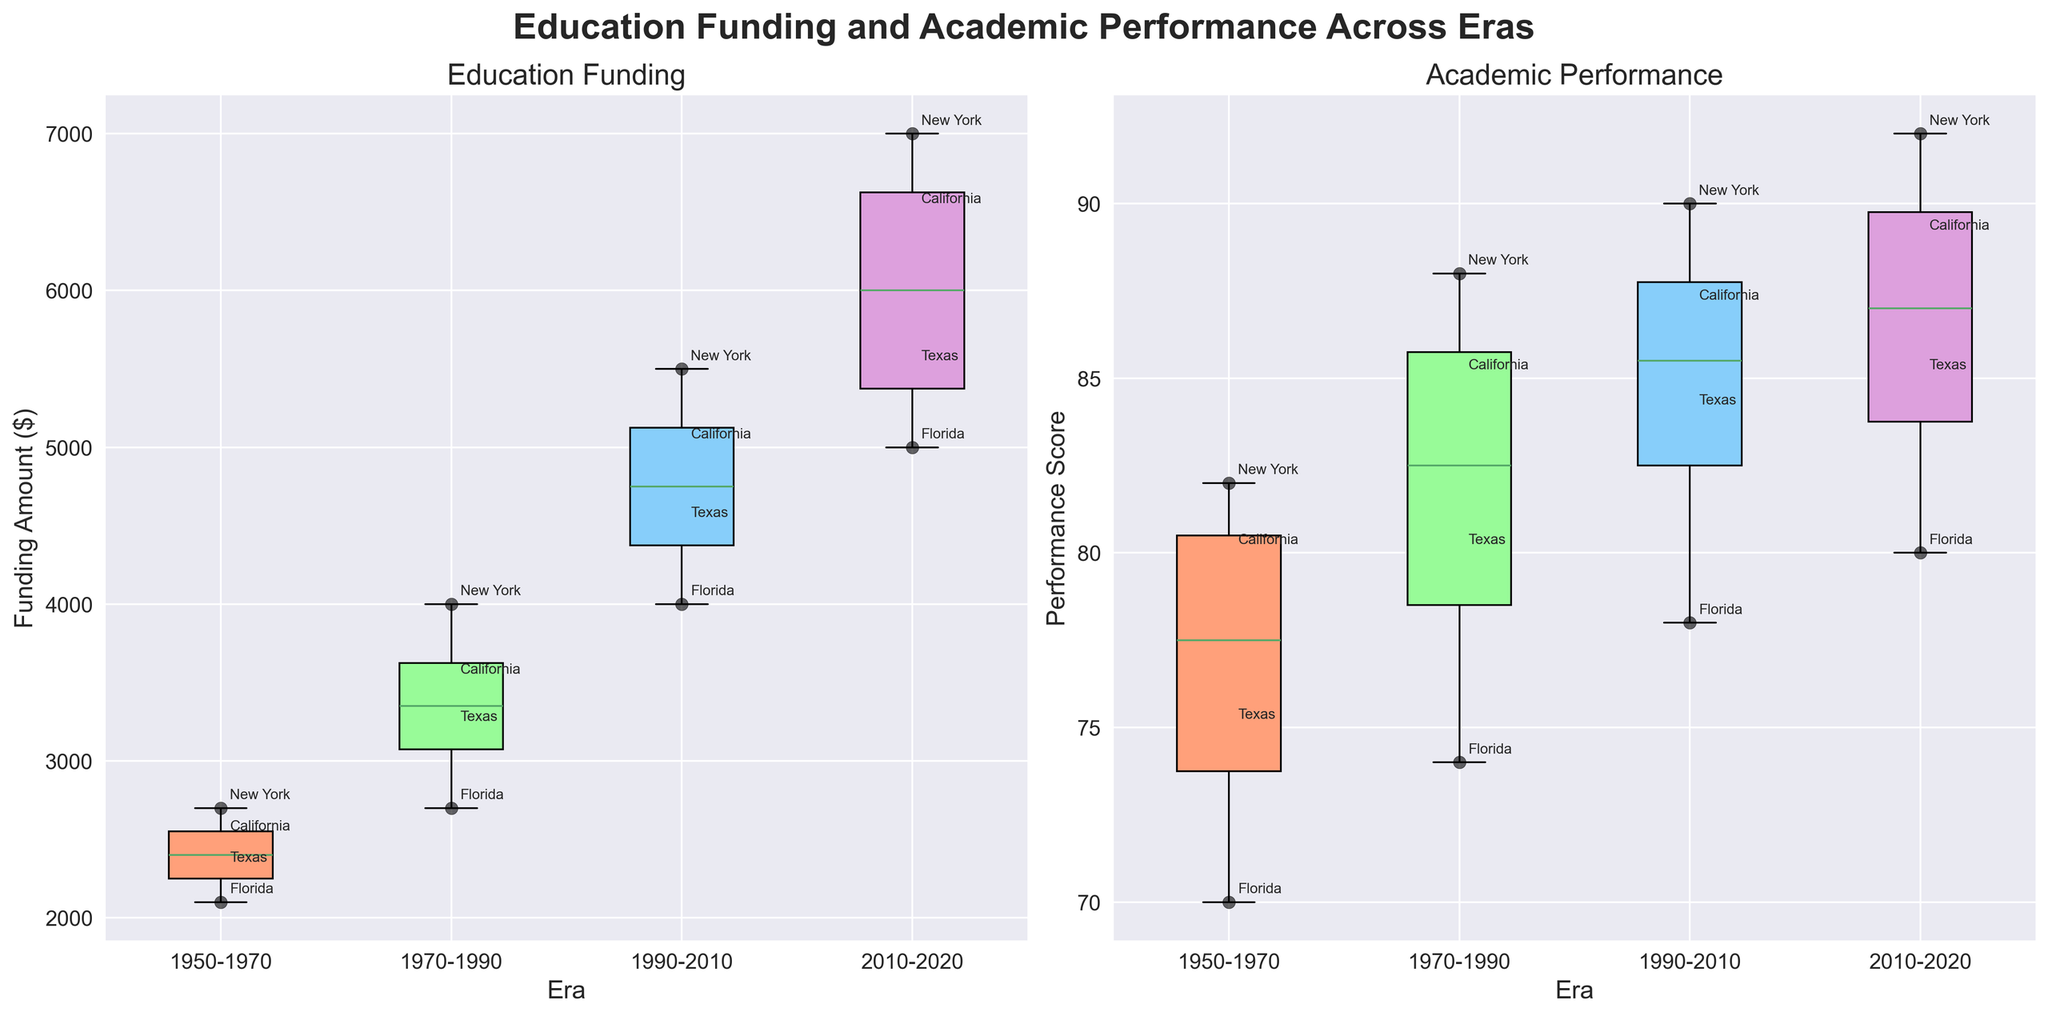What's the title of the figure? The title of the figure is displayed prominently at the top of the visualization. It reads "Education Funding and Academic Performance Across Eras".
Answer: Education Funding and Academic Performance Across Eras Which state shows the lowest education funding in the era 1950-1970? By looking at the box plot for Education Funding in the 1950-1970 era, you should locate the points representing each state. Florida has the lowest funding visible at $2100.
Answer: Florida How does the academic performance in California compare between the 1950-1970 era and the 2010-2020 era? From the Academic Performance box plots, find the points for California in both eras. In the 1950-1970 era, California's performance is at 80, while in the 2010-2020 era, it is at 89. California's performance improved by 9 points over time.
Answer: Improved by 9 points What's the average education funding for the era 1970-1990? Find the values for education funding in the 1970-1990 era: 3500, 4000, 3200, and 2700. Their sum is 13400, and there are 4 data points. So, the average funding is 13400 / 4 = 3350.
Answer: 3350 Which era shows the highest median academic performance? To identify the era with the highest median academic performance, observe the central line (which represents the median) of the box plots for academic performance across all eras. The 2010-2020 era has the highest median academic performance.
Answer: 2010-2020 Is there a correlation between education funding and academic performance across the eras? Compare the box plots for Education Funding and Academic Performance across the eras. Observe if higher funding correlates with higher performance. Generally, we see higher education funding corresponds to better academic performance in successive eras.
Answer: Yes What's the range of academic performance scores for Texas in the dataset? Look at the academic performance points annotated for Texas in each era: 75, 80, 84, 85. The range is the difference between the highest and lowest values: 85 - 75 = 10.
Answer: 10 During which era did New York have the highest education funding? Look at the Education Funding box plots, identify the points for New York across all eras. The highest value is in the 2010-2020 era with $7000.
Answer: 2010-2020 By how much did Florida's education funding increase from the era 1950-1970 to the era 2010-2020? Find Florida's education funding values in both eras: $2100 for 1950-1970 and $5000 for 2010-2020. The increase is $5000 - $2100 = $2900.
Answer: $2900 